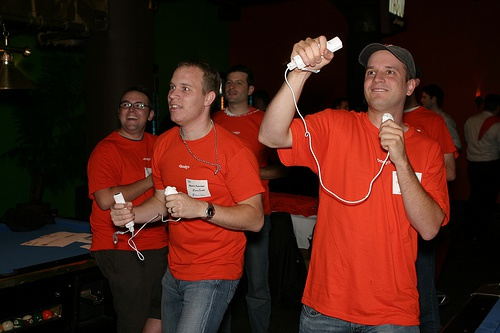Describe the objects in this image and their specific colors. I can see people in black, red, and brown tones, people in black, brown, and red tones, people in black, maroon, and brown tones, people in black, maroon, and brown tones, and people in black tones in this image. 